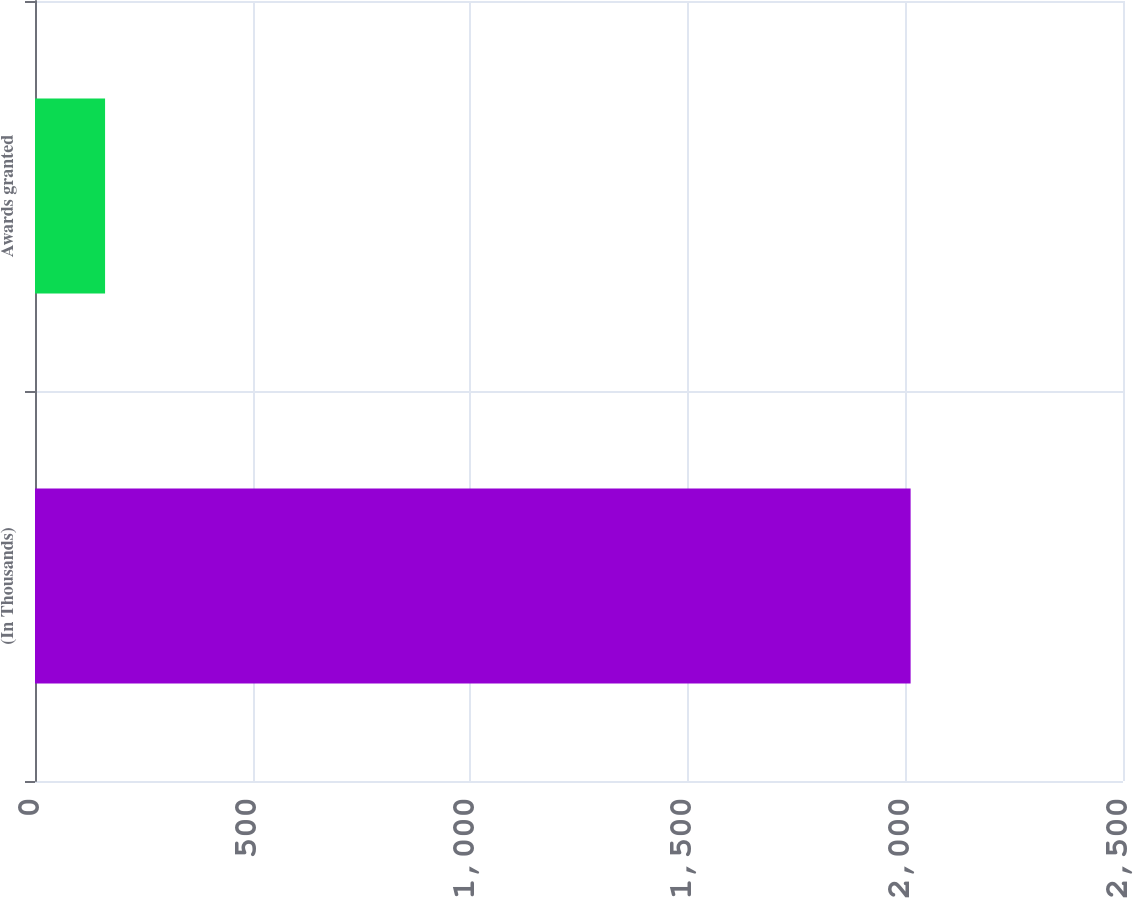Convert chart to OTSL. <chart><loc_0><loc_0><loc_500><loc_500><bar_chart><fcel>(In Thousands)<fcel>Awards granted<nl><fcel>2012<fcel>161<nl></chart> 